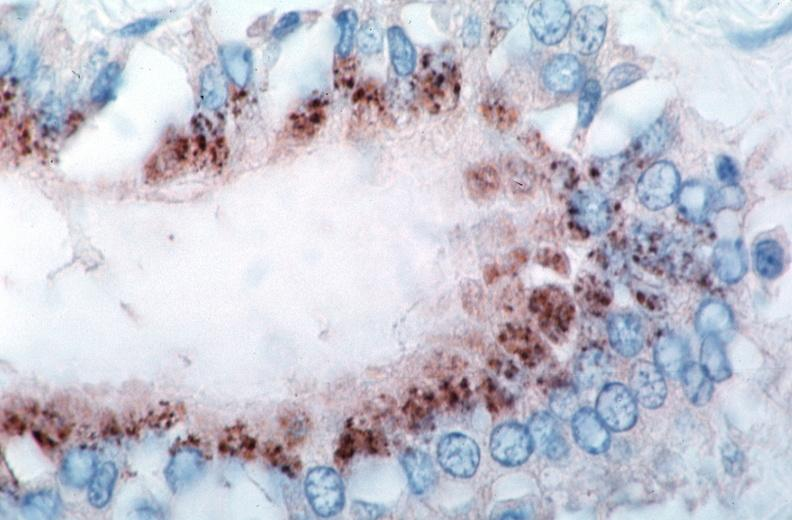s cardiovascular present?
Answer the question using a single word or phrase. Yes 